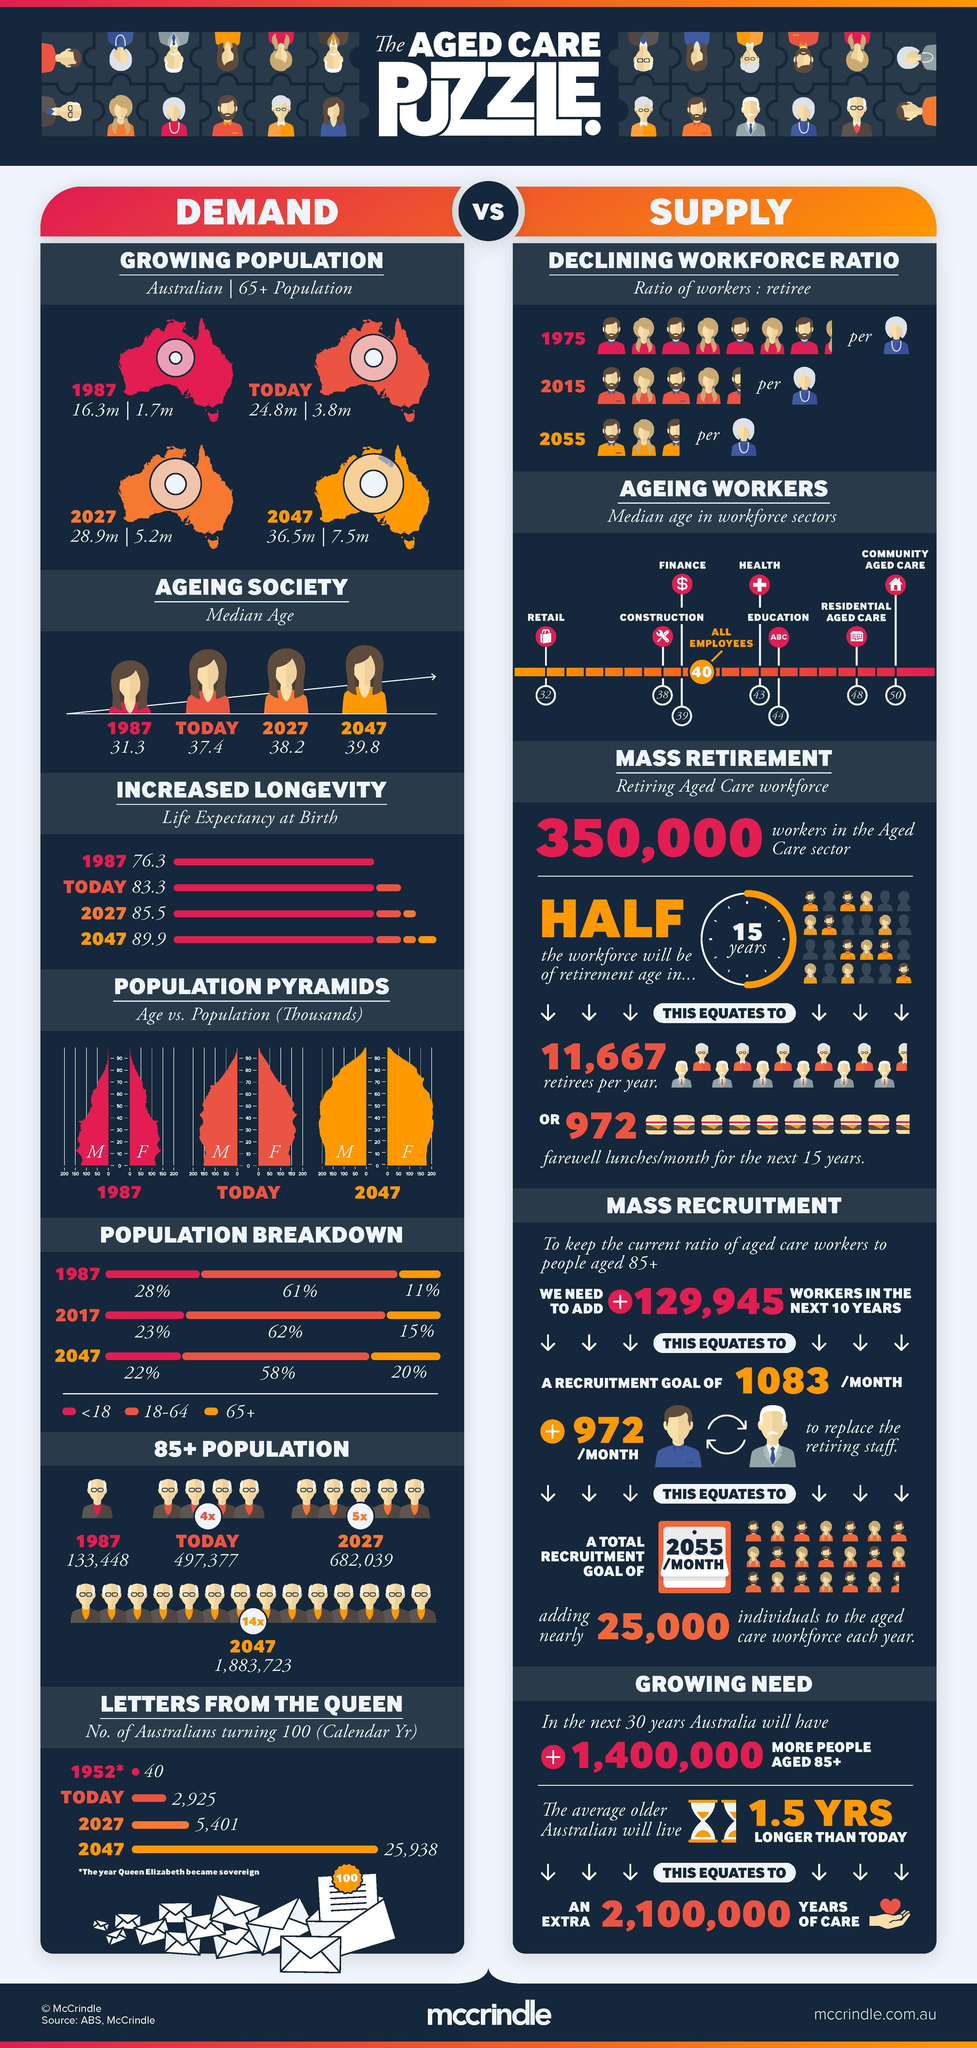What is the percentage of Australians aged under 18 years in 2017?
Answer the question with a short phrase. 23% What is the population of Australians aged 65+ years in 1987? 1.7m What is the estimated population of Australians aged 85+ years by 2027? 682,039 What is the estimated population of Australians aged 65+ years by 2027? 5.2m What is the life expectancy of Australians at birth in 1987? 76.3 What is the percentage of Australians in the age group of 18-64 years in 2017? 62% What is the median age of workforce in the retail sector? 32 What is the estimated population of Australians by 2047? 36.5m What is the percentage of Australians aged 65+ years in 1987? 11% 